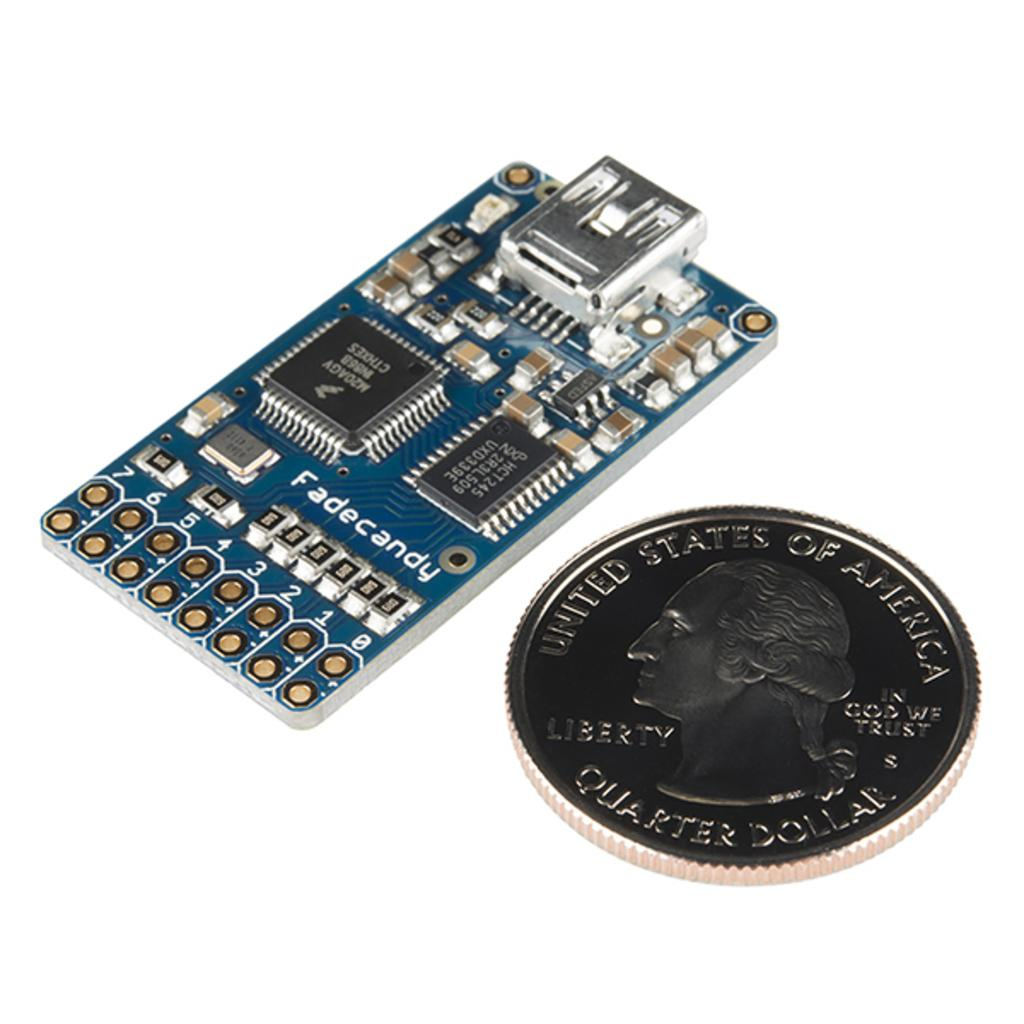What is the main subject of the image? The main subject of the image is an electronic circuit board. Are there any other objects visible in the image? Yes, there is a coin on the right side of the image. What type of straw is being used to stir the eggnog in the image? There is no eggnog or straw present in the image; it contains an electronic circuit board and a coin. 